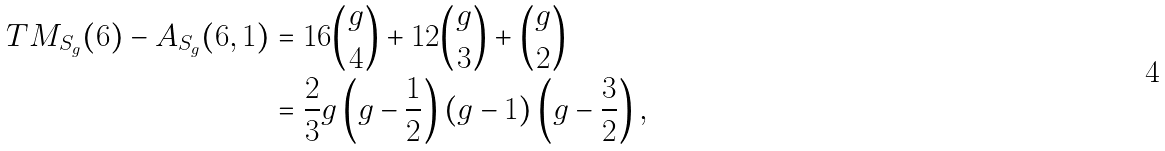<formula> <loc_0><loc_0><loc_500><loc_500>T M _ { S _ { g } } ( 6 ) - A _ { S _ { g } } ( 6 , 1 ) & = 1 6 \binom { g } { 4 } + 1 2 \binom { g } { 3 } + \binom { g } { 2 } \\ & = \frac { 2 } { 3 } g \left ( g - \frac { 1 } { 2 } \right ) \left ( g - 1 \right ) \left ( g - \frac { 3 } { 2 } \right ) ,</formula> 